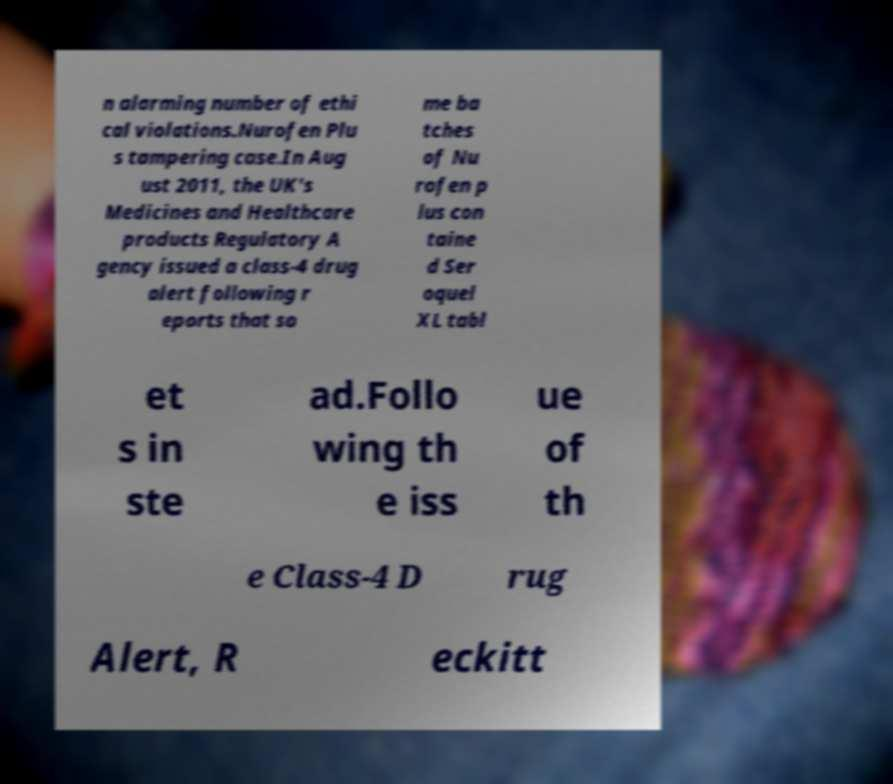Could you extract and type out the text from this image? n alarming number of ethi cal violations.Nurofen Plu s tampering case.In Aug ust 2011, the UK's Medicines and Healthcare products Regulatory A gency issued a class-4 drug alert following r eports that so me ba tches of Nu rofen p lus con taine d Ser oquel XL tabl et s in ste ad.Follo wing th e iss ue of th e Class-4 D rug Alert, R eckitt 